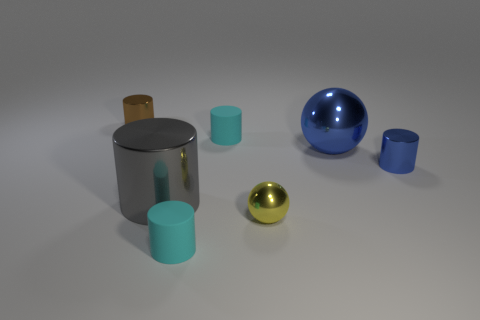Subtract all brown cylinders. How many cylinders are left? 4 Subtract all brown metal cylinders. How many cylinders are left? 4 Subtract 1 cylinders. How many cylinders are left? 4 Subtract all purple cylinders. Subtract all cyan blocks. How many cylinders are left? 5 Add 1 large yellow metal balls. How many objects exist? 8 Subtract all balls. How many objects are left? 5 Add 2 small yellow things. How many small yellow things are left? 3 Add 5 cyan matte cylinders. How many cyan matte cylinders exist? 7 Subtract 0 brown blocks. How many objects are left? 7 Subtract all tiny blue metal cylinders. Subtract all gray shiny cylinders. How many objects are left? 5 